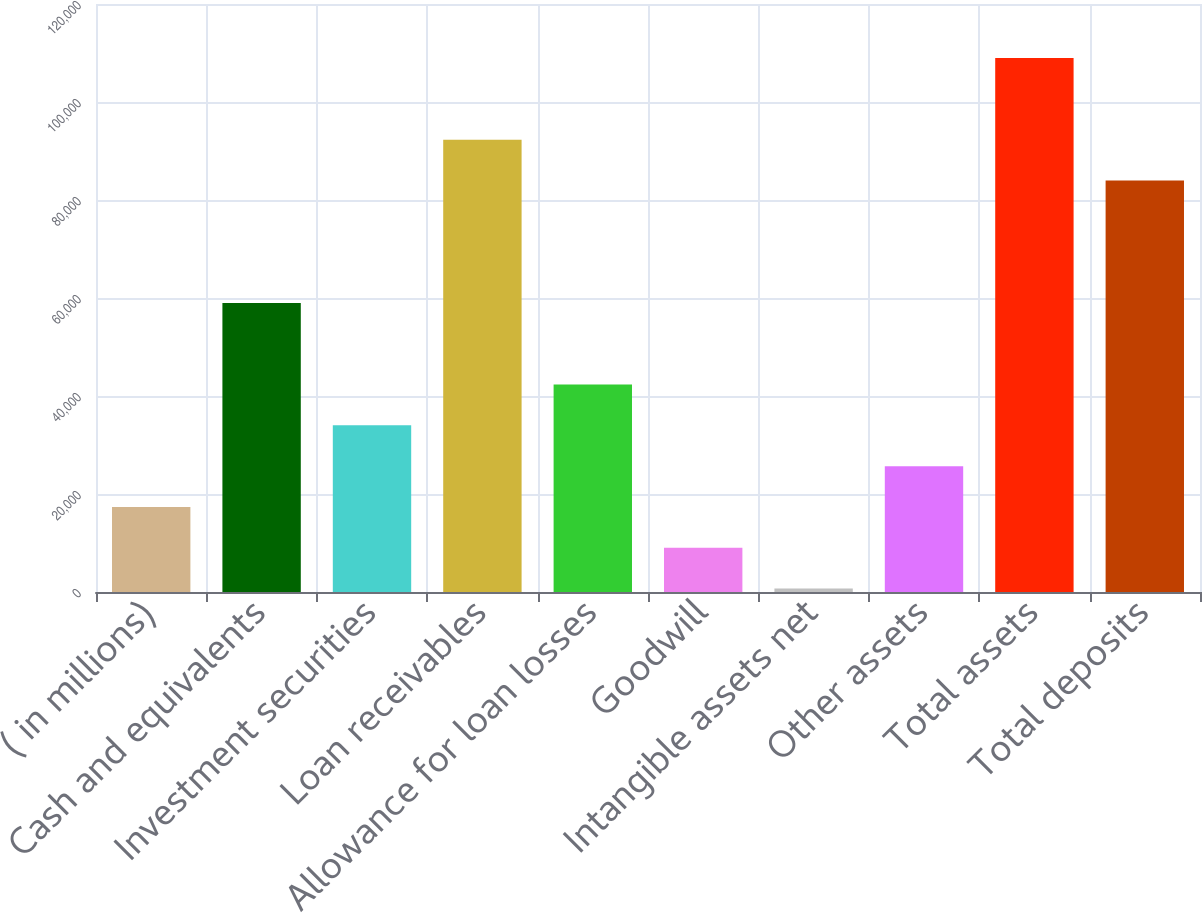Convert chart to OTSL. <chart><loc_0><loc_0><loc_500><loc_500><bar_chart><fcel>( in millions)<fcel>Cash and equivalents<fcel>Investment securities<fcel>Loan receivables<fcel>Allowance for loan losses<fcel>Goodwill<fcel>Intangible assets net<fcel>Other assets<fcel>Total assets<fcel>Total deposits<nl><fcel>17358.8<fcel>59003.3<fcel>34016.6<fcel>92318.9<fcel>42345.5<fcel>9029.9<fcel>701<fcel>25687.7<fcel>108977<fcel>83990<nl></chart> 